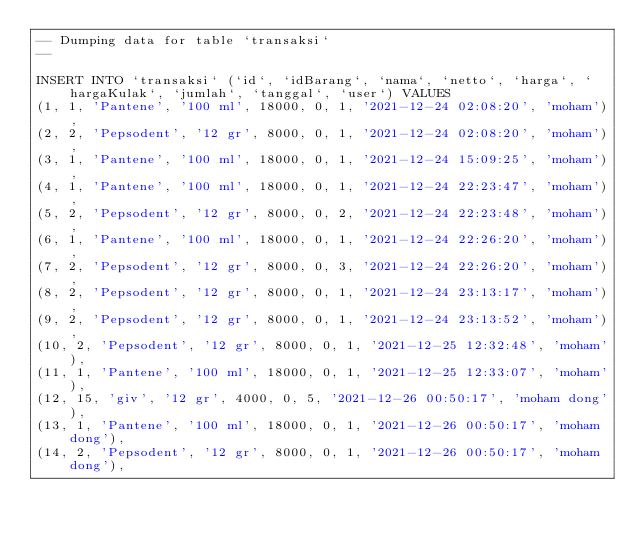Convert code to text. <code><loc_0><loc_0><loc_500><loc_500><_SQL_>-- Dumping data for table `transaksi`
--

INSERT INTO `transaksi` (`id`, `idBarang`, `nama`, `netto`, `harga`, `hargaKulak`, `jumlah`, `tanggal`, `user`) VALUES
(1, 1, 'Pantene', '100 ml', 18000, 0, 1, '2021-12-24 02:08:20', 'moham'),
(2, 2, 'Pepsodent', '12 gr', 8000, 0, 1, '2021-12-24 02:08:20', 'moham'),
(3, 1, 'Pantene', '100 ml', 18000, 0, 1, '2021-12-24 15:09:25', 'moham'),
(4, 1, 'Pantene', '100 ml', 18000, 0, 1, '2021-12-24 22:23:47', 'moham'),
(5, 2, 'Pepsodent', '12 gr', 8000, 0, 2, '2021-12-24 22:23:48', 'moham'),
(6, 1, 'Pantene', '100 ml', 18000, 0, 1, '2021-12-24 22:26:20', 'moham'),
(7, 2, 'Pepsodent', '12 gr', 8000, 0, 3, '2021-12-24 22:26:20', 'moham'),
(8, 2, 'Pepsodent', '12 gr', 8000, 0, 1, '2021-12-24 23:13:17', 'moham'),
(9, 2, 'Pepsodent', '12 gr', 8000, 0, 1, '2021-12-24 23:13:52', 'moham'),
(10, 2, 'Pepsodent', '12 gr', 8000, 0, 1, '2021-12-25 12:32:48', 'moham'),
(11, 1, 'Pantene', '100 ml', 18000, 0, 1, '2021-12-25 12:33:07', 'moham'),
(12, 15, 'giv', '12 gr', 4000, 0, 5, '2021-12-26 00:50:17', 'moham dong'),
(13, 1, 'Pantene', '100 ml', 18000, 0, 1, '2021-12-26 00:50:17', 'moham dong'),
(14, 2, 'Pepsodent', '12 gr', 8000, 0, 1, '2021-12-26 00:50:17', 'moham dong'),</code> 